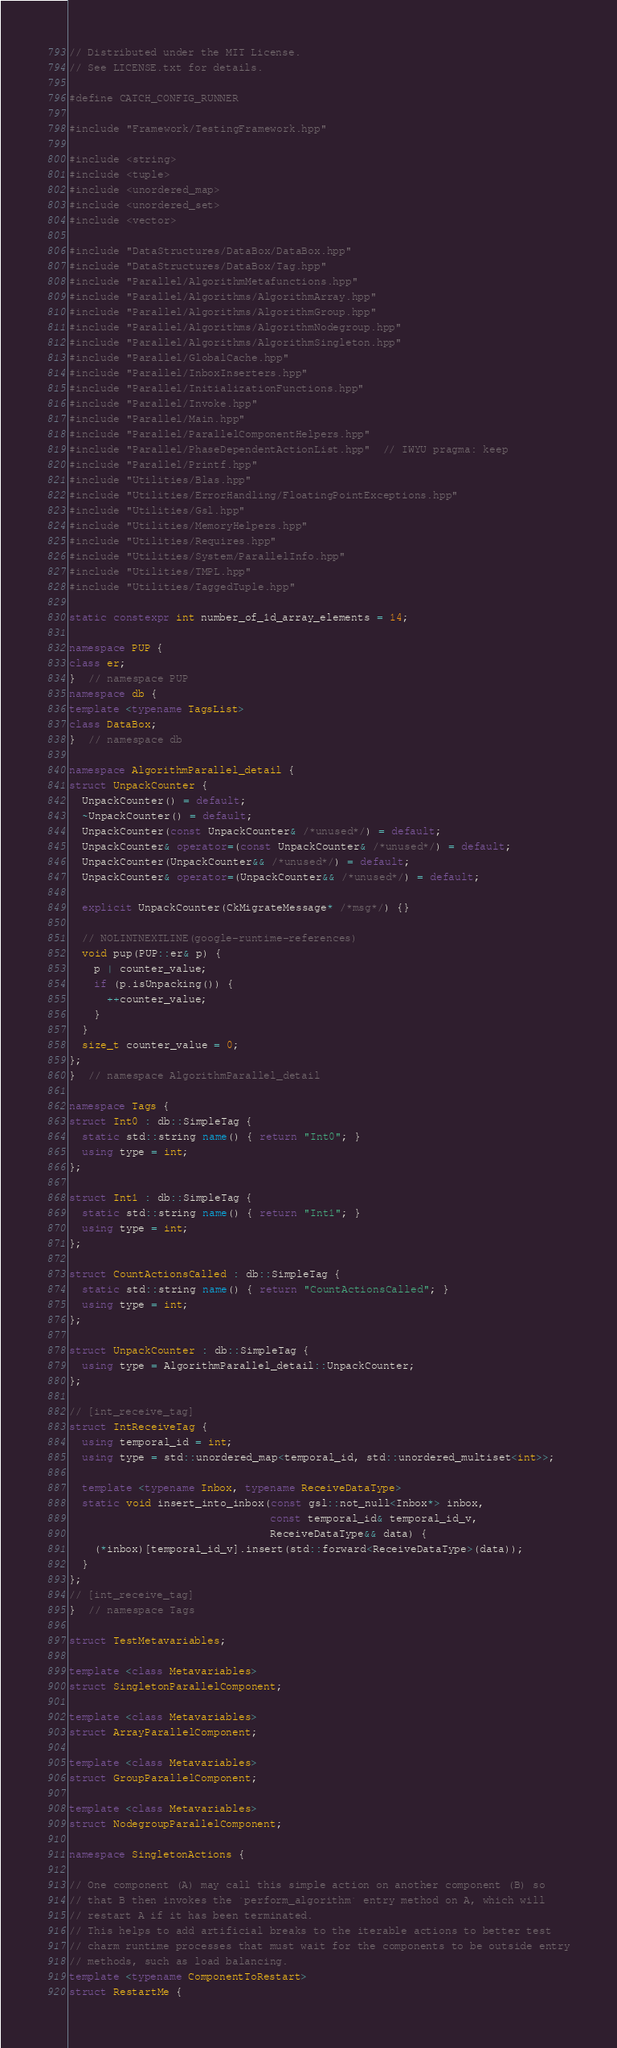Convert code to text. <code><loc_0><loc_0><loc_500><loc_500><_C++_>// Distributed under the MIT License.
// See LICENSE.txt for details.

#define CATCH_CONFIG_RUNNER

#include "Framework/TestingFramework.hpp"

#include <string>
#include <tuple>
#include <unordered_map>
#include <unordered_set>
#include <vector>

#include "DataStructures/DataBox/DataBox.hpp"
#include "DataStructures/DataBox/Tag.hpp"
#include "Parallel/AlgorithmMetafunctions.hpp"
#include "Parallel/Algorithms/AlgorithmArray.hpp"
#include "Parallel/Algorithms/AlgorithmGroup.hpp"
#include "Parallel/Algorithms/AlgorithmNodegroup.hpp"
#include "Parallel/Algorithms/AlgorithmSingleton.hpp"
#include "Parallel/GlobalCache.hpp"
#include "Parallel/InboxInserters.hpp"
#include "Parallel/InitializationFunctions.hpp"
#include "Parallel/Invoke.hpp"
#include "Parallel/Main.hpp"
#include "Parallel/ParallelComponentHelpers.hpp"
#include "Parallel/PhaseDependentActionList.hpp"  // IWYU pragma: keep
#include "Parallel/Printf.hpp"
#include "Utilities/Blas.hpp"
#include "Utilities/ErrorHandling/FloatingPointExceptions.hpp"
#include "Utilities/Gsl.hpp"
#include "Utilities/MemoryHelpers.hpp"
#include "Utilities/Requires.hpp"
#include "Utilities/System/ParallelInfo.hpp"
#include "Utilities/TMPL.hpp"
#include "Utilities/TaggedTuple.hpp"

static constexpr int number_of_1d_array_elements = 14;

namespace PUP {
class er;
}  // namespace PUP
namespace db {
template <typename TagsList>
class DataBox;
}  // namespace db

namespace AlgorithmParallel_detail {
struct UnpackCounter {
  UnpackCounter() = default;
  ~UnpackCounter() = default;
  UnpackCounter(const UnpackCounter& /*unused*/) = default;
  UnpackCounter& operator=(const UnpackCounter& /*unused*/) = default;
  UnpackCounter(UnpackCounter&& /*unused*/) = default;
  UnpackCounter& operator=(UnpackCounter&& /*unused*/) = default;

  explicit UnpackCounter(CkMigrateMessage* /*msg*/) {}

  // NOLINTNEXTLINE(google-runtime-references)
  void pup(PUP::er& p) {
    p | counter_value;
    if (p.isUnpacking()) {
      ++counter_value;
    }
  }
  size_t counter_value = 0;
};
}  // namespace AlgorithmParallel_detail

namespace Tags {
struct Int0 : db::SimpleTag {
  static std::string name() { return "Int0"; }
  using type = int;
};

struct Int1 : db::SimpleTag {
  static std::string name() { return "Int1"; }
  using type = int;
};

struct CountActionsCalled : db::SimpleTag {
  static std::string name() { return "CountActionsCalled"; }
  using type = int;
};

struct UnpackCounter : db::SimpleTag {
  using type = AlgorithmParallel_detail::UnpackCounter;
};

// [int_receive_tag]
struct IntReceiveTag {
  using temporal_id = int;
  using type = std::unordered_map<temporal_id, std::unordered_multiset<int>>;

  template <typename Inbox, typename ReceiveDataType>
  static void insert_into_inbox(const gsl::not_null<Inbox*> inbox,
                                const temporal_id& temporal_id_v,
                                ReceiveDataType&& data) {
    (*inbox)[temporal_id_v].insert(std::forward<ReceiveDataType>(data));
  }
};
// [int_receive_tag]
}  // namespace Tags

struct TestMetavariables;

template <class Metavariables>
struct SingletonParallelComponent;

template <class Metavariables>
struct ArrayParallelComponent;

template <class Metavariables>
struct GroupParallelComponent;

template <class Metavariables>
struct NodegroupParallelComponent;

namespace SingletonActions {

// One component (A) may call this simple action on another component (B) so
// that B then invokes the `perform_algorithm` entry method on A, which will
// restart A if it has been terminated.
// This helps to add artificial breaks to the iterable actions to better test
// charm runtime processes that must wait for the components to be outside entry
// methods, such as load balancing.
template <typename ComponentToRestart>
struct RestartMe {</code> 